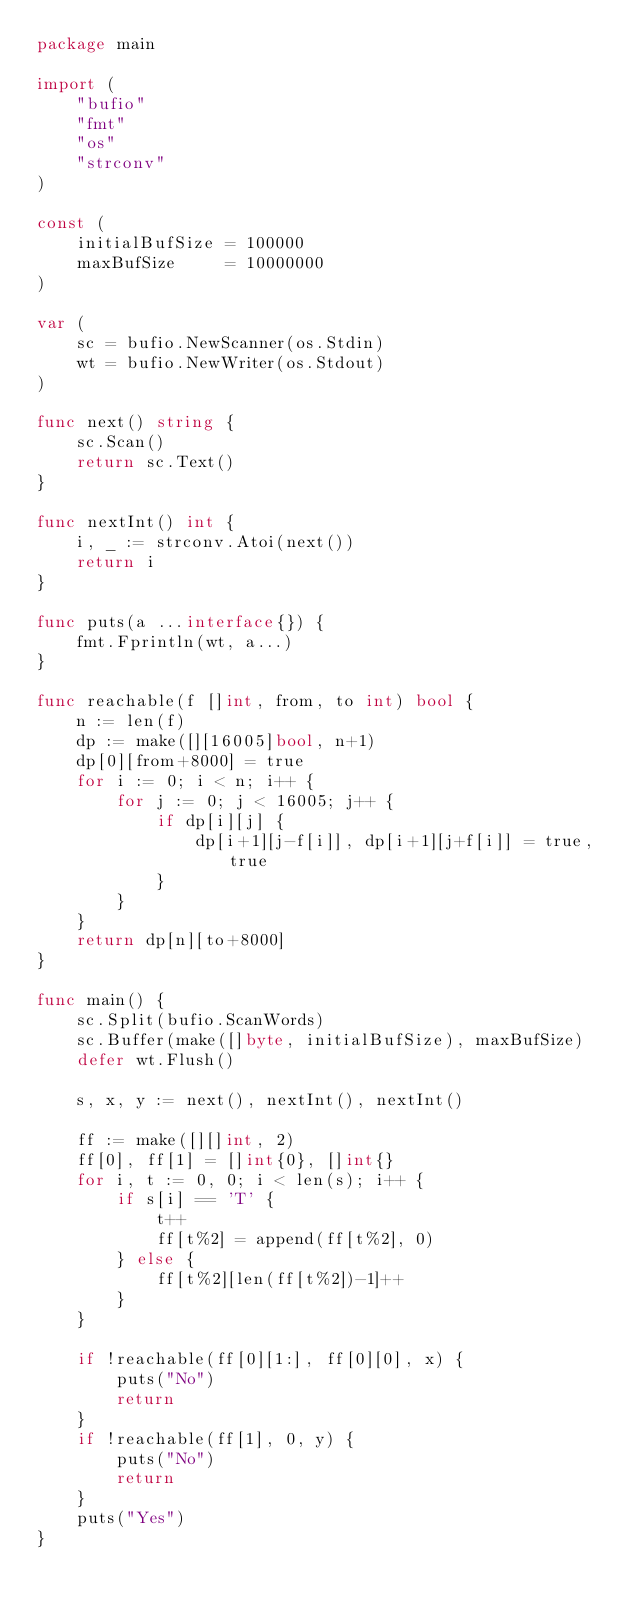Convert code to text. <code><loc_0><loc_0><loc_500><loc_500><_Go_>package main

import (
	"bufio"
	"fmt"
	"os"
	"strconv"
)

const (
	initialBufSize = 100000
	maxBufSize     = 10000000
)

var (
	sc = bufio.NewScanner(os.Stdin)
	wt = bufio.NewWriter(os.Stdout)
)

func next() string {
	sc.Scan()
	return sc.Text()
}

func nextInt() int {
	i, _ := strconv.Atoi(next())
	return i
}

func puts(a ...interface{}) {
	fmt.Fprintln(wt, a...)
}

func reachable(f []int, from, to int) bool {
	n := len(f)
	dp := make([][16005]bool, n+1)
	dp[0][from+8000] = true
	for i := 0; i < n; i++ {
		for j := 0; j < 16005; j++ {
			if dp[i][j] {
				dp[i+1][j-f[i]], dp[i+1][j+f[i]] = true, true
			}
		}
	}
	return dp[n][to+8000]
}

func main() {
	sc.Split(bufio.ScanWords)
	sc.Buffer(make([]byte, initialBufSize), maxBufSize)
	defer wt.Flush()

	s, x, y := next(), nextInt(), nextInt()

	ff := make([][]int, 2)
	ff[0], ff[1] = []int{0}, []int{}
	for i, t := 0, 0; i < len(s); i++ {
		if s[i] == 'T' {
			t++
			ff[t%2] = append(ff[t%2], 0)
		} else {
			ff[t%2][len(ff[t%2])-1]++
		}
	}

	if !reachable(ff[0][1:], ff[0][0], x) {
		puts("No")
		return
	}
	if !reachable(ff[1], 0, y) {
		puts("No")
		return
	}
	puts("Yes")
}
</code> 